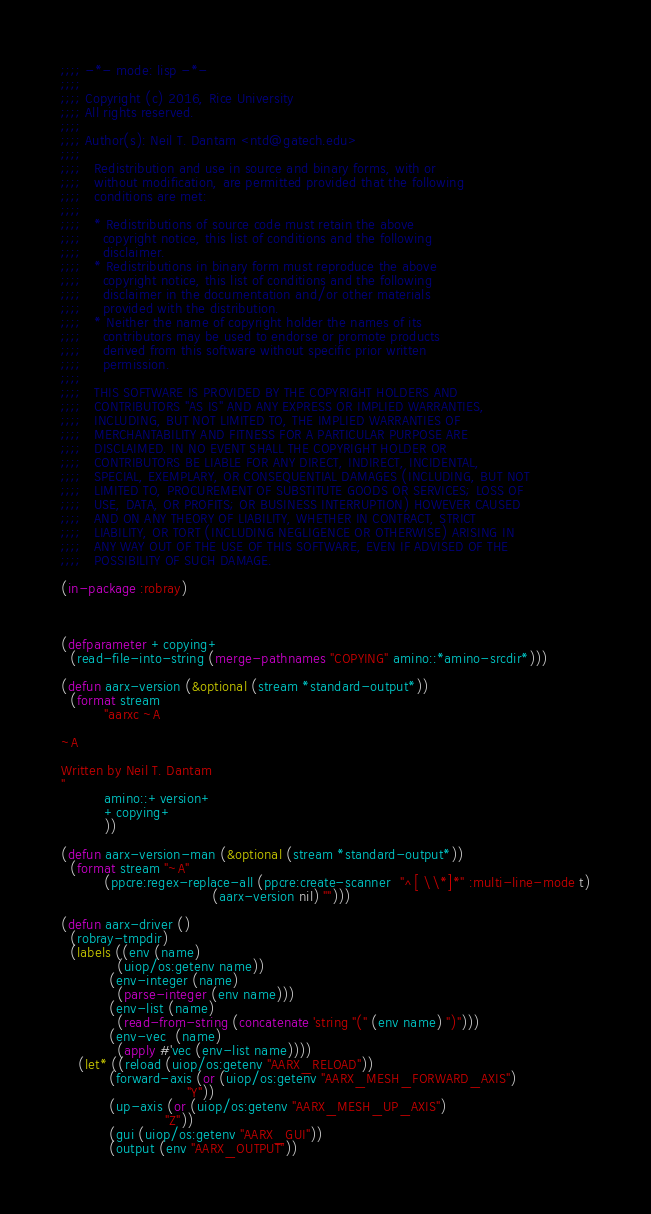Convert code to text. <code><loc_0><loc_0><loc_500><loc_500><_Lisp_>;;;; -*- mode: lisp -*-
;;;;
;;;; Copyright (c) 2016, Rice University
;;;; All rights reserved.
;;;;
;;;; Author(s): Neil T. Dantam <ntd@gatech.edu>
;;;;
;;;;   Redistribution and use in source and binary forms, with or
;;;;   without modification, are permitted provided that the following
;;;;   conditions are met:
;;;;
;;;;   * Redistributions of source code must retain the above
;;;;     copyright notice, this list of conditions and the following
;;;;     disclaimer.
;;;;   * Redistributions in binary form must reproduce the above
;;;;     copyright notice, this list of conditions and the following
;;;;     disclaimer in the documentation and/or other materials
;;;;     provided with the distribution.
;;;;   * Neither the name of copyright holder the names of its
;;;;     contributors may be used to endorse or promote products
;;;;     derived from this software without specific prior written
;;;;     permission.
;;;;
;;;;   THIS SOFTWARE IS PROVIDED BY THE COPYRIGHT HOLDERS AND
;;;;   CONTRIBUTORS "AS IS" AND ANY EXPRESS OR IMPLIED WARRANTIES,
;;;;   INCLUDING, BUT NOT LIMITED TO, THE IMPLIED WARRANTIES OF
;;;;   MERCHANTABILITY AND FITNESS FOR A PARTICULAR PURPOSE ARE
;;;;   DISCLAIMED. IN NO EVENT SHALL THE COPYRIGHT HOLDER OR
;;;;   CONTRIBUTORS BE LIABLE FOR ANY DIRECT, INDIRECT, INCIDENTAL,
;;;;   SPECIAL, EXEMPLARY, OR CONSEQUENTIAL DAMAGES (INCLUDING, BUT NOT
;;;;   LIMITED TO, PROCUREMENT OF SUBSTITUTE GOODS OR SERVICES; LOSS OF
;;;;   USE, DATA, OR PROFITS; OR BUSINESS INTERRUPTION) HOWEVER CAUSED
;;;;   AND ON ANY THEORY OF LIABILITY, WHETHER IN CONTRACT, STRICT
;;;;   LIABILITY, OR TORT (INCLUDING NEGLIGENCE OR OTHERWISE) ARISING IN
;;;;   ANY WAY OUT OF THE USE OF THIS SOFTWARE, EVEN IF ADVISED OF THE
;;;;   POSSIBILITY OF SUCH DAMAGE.

(in-package :robray)



(defparameter +copying+
  (read-file-into-string (merge-pathnames "COPYING" amino::*amino-srcdir*)))

(defun aarx-version (&optional (stream *standard-output*))
  (format stream
          "aarxc ~A

~A

Written by Neil T. Dantam
"
          amino::+version+
          +copying+
          ))

(defun aarx-version-man (&optional (stream *standard-output*))
  (format stream "~A"
          (ppcre:regex-replace-all (ppcre:create-scanner  "^[ \\*]*" :multi-line-mode t)
                                   (aarx-version nil) "")))

(defun aarx-driver ()
  (robray-tmpdir)
  (labels ((env (name)
             (uiop/os:getenv name))
           (env-integer (name)
             (parse-integer (env name)))
           (env-list (name)
             (read-from-string (concatenate 'string "(" (env name) ")")))
           (env-vec  (name)
             (apply #'vec (env-list name))))
    (let* ((reload (uiop/os:getenv "AARX_RELOAD"))
           (forward-axis (or (uiop/os:getenv "AARX_MESH_FORWARD_AXIS")
                             "Y"))
           (up-axis (or (uiop/os:getenv "AARX_MESH_UP_AXIS")
                        "Z"))
           (gui (uiop/os:getenv "AARX_GUI"))
           (output (env "AARX_OUTPUT"))</code> 